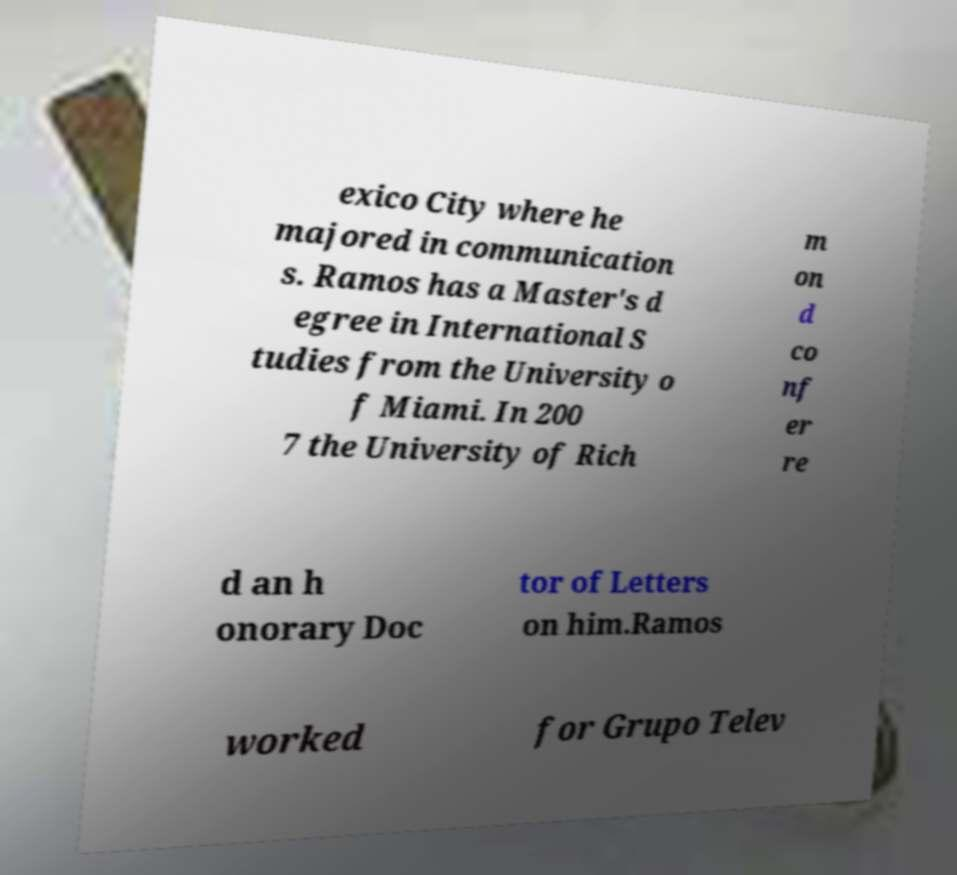Could you assist in decoding the text presented in this image and type it out clearly? exico City where he majored in communication s. Ramos has a Master's d egree in International S tudies from the University o f Miami. In 200 7 the University of Rich m on d co nf er re d an h onorary Doc tor of Letters on him.Ramos worked for Grupo Telev 